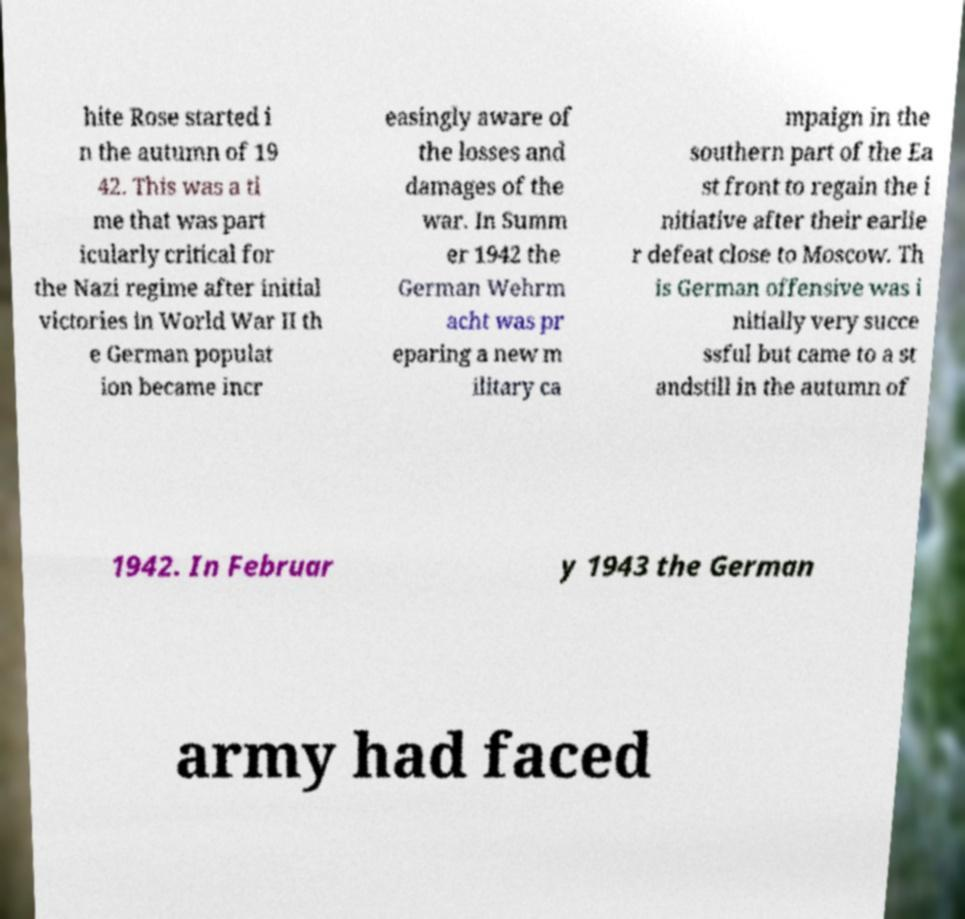I need the written content from this picture converted into text. Can you do that? hite Rose started i n the autumn of 19 42. This was a ti me that was part icularly critical for the Nazi regime after initial victories in World War II th e German populat ion became incr easingly aware of the losses and damages of the war. In Summ er 1942 the German Wehrm acht was pr eparing a new m ilitary ca mpaign in the southern part of the Ea st front to regain the i nitiative after their earlie r defeat close to Moscow. Th is German offensive was i nitially very succe ssful but came to a st andstill in the autumn of 1942. In Februar y 1943 the German army had faced 